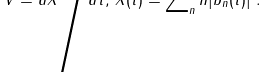Convert formula to latex. <formula><loc_0><loc_0><loc_500><loc_500>V = d X \Big / d \tilde { t } , \, X ( \tilde { t } ) = \sum \nolimits _ { n } n | b _ { n } ( \tilde { t } ) | ^ { 2 } .</formula> 